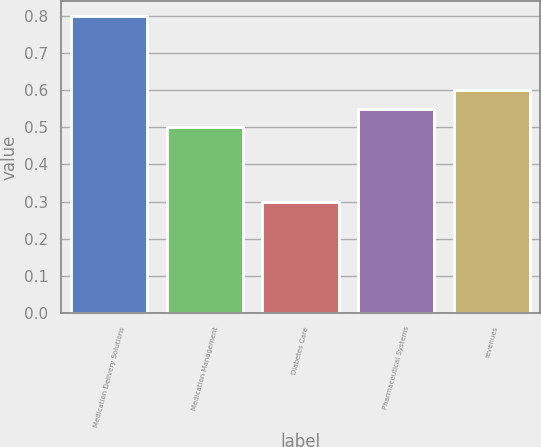Convert chart to OTSL. <chart><loc_0><loc_0><loc_500><loc_500><bar_chart><fcel>Medication Delivery Solutions<fcel>Medication Management<fcel>Diabetes Care<fcel>Pharmaceutical Systems<fcel>revenues<nl><fcel>0.8<fcel>0.5<fcel>0.3<fcel>0.55<fcel>0.6<nl></chart> 